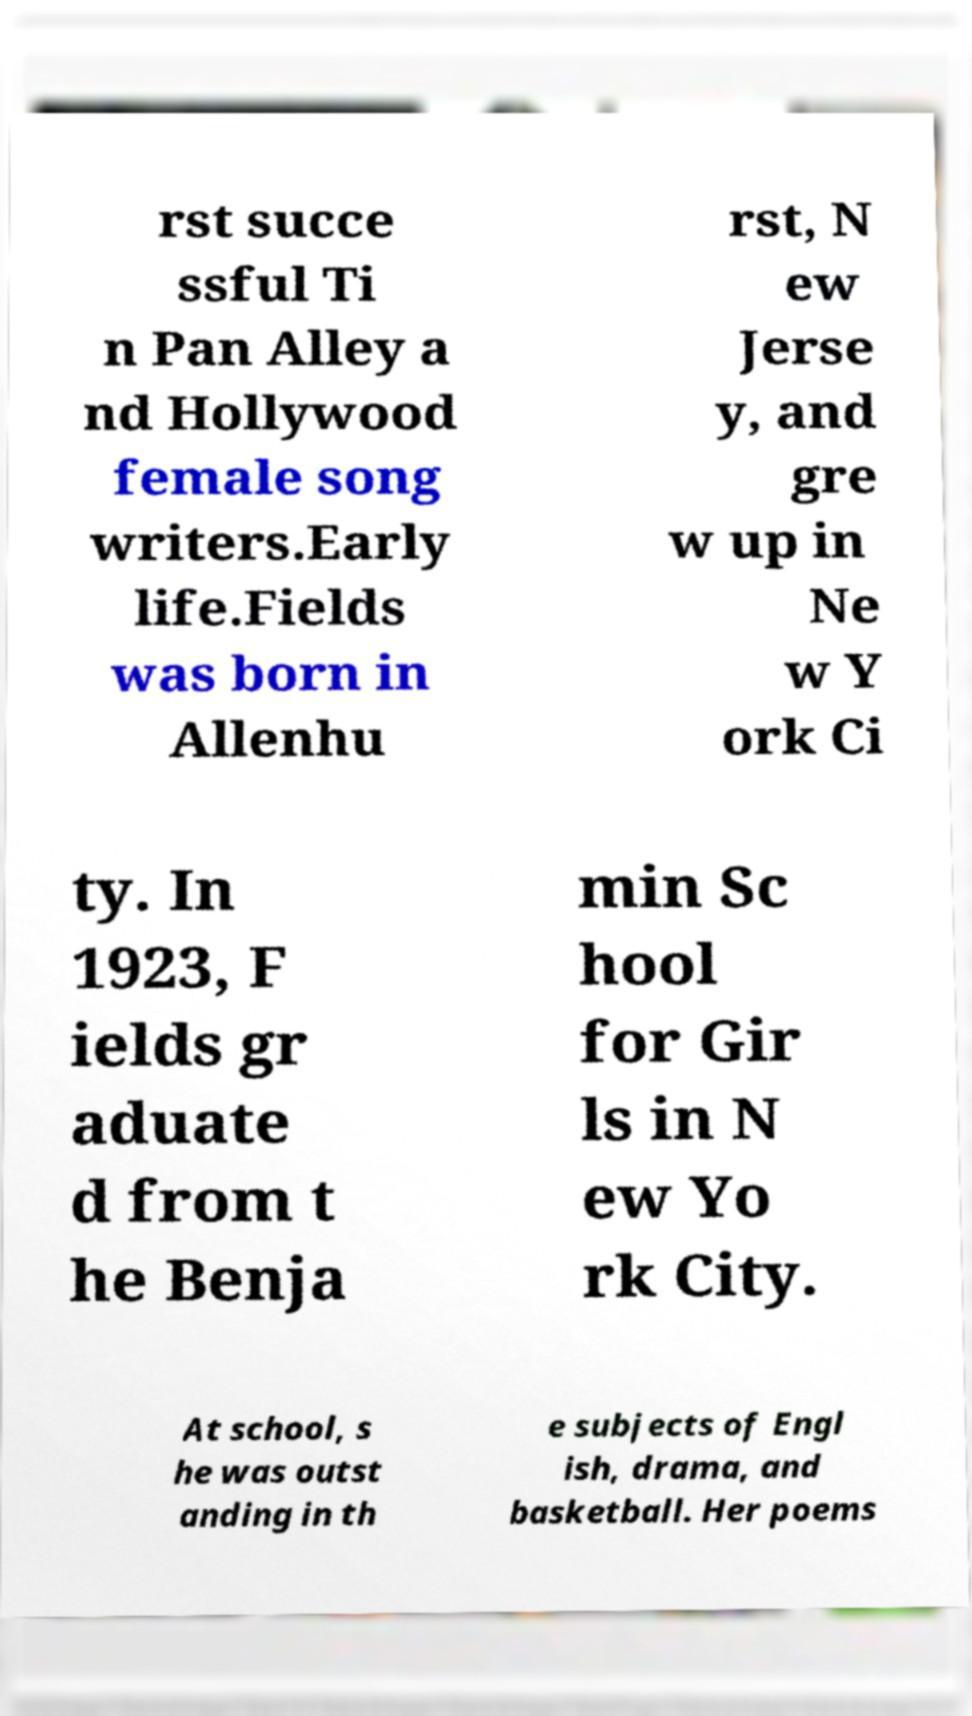Can you accurately transcribe the text from the provided image for me? rst succe ssful Ti n Pan Alley a nd Hollywood female song writers.Early life.Fields was born in Allenhu rst, N ew Jerse y, and gre w up in Ne w Y ork Ci ty. In 1923, F ields gr aduate d from t he Benja min Sc hool for Gir ls in N ew Yo rk City. At school, s he was outst anding in th e subjects of Engl ish, drama, and basketball. Her poems 